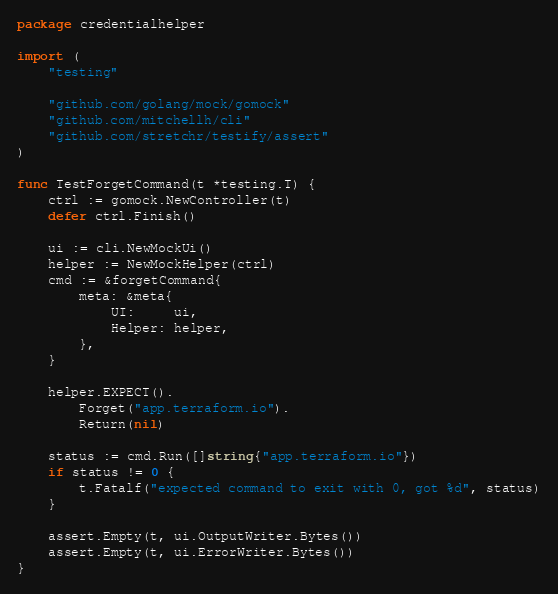Convert code to text. <code><loc_0><loc_0><loc_500><loc_500><_Go_>package credentialhelper

import (
	"testing"

	"github.com/golang/mock/gomock"
	"github.com/mitchellh/cli"
	"github.com/stretchr/testify/assert"
)

func TestForgetCommand(t *testing.T) {
	ctrl := gomock.NewController(t)
	defer ctrl.Finish()

	ui := cli.NewMockUi()
	helper := NewMockHelper(ctrl)
	cmd := &forgetCommand{
		meta: &meta{
			UI:     ui,
			Helper: helper,
		},
	}

	helper.EXPECT().
		Forget("app.terraform.io").
		Return(nil)

	status := cmd.Run([]string{"app.terraform.io"})
	if status != 0 {
		t.Fatalf("expected command to exit with 0, got %d", status)
	}

	assert.Empty(t, ui.OutputWriter.Bytes())
	assert.Empty(t, ui.ErrorWriter.Bytes())
}
</code> 